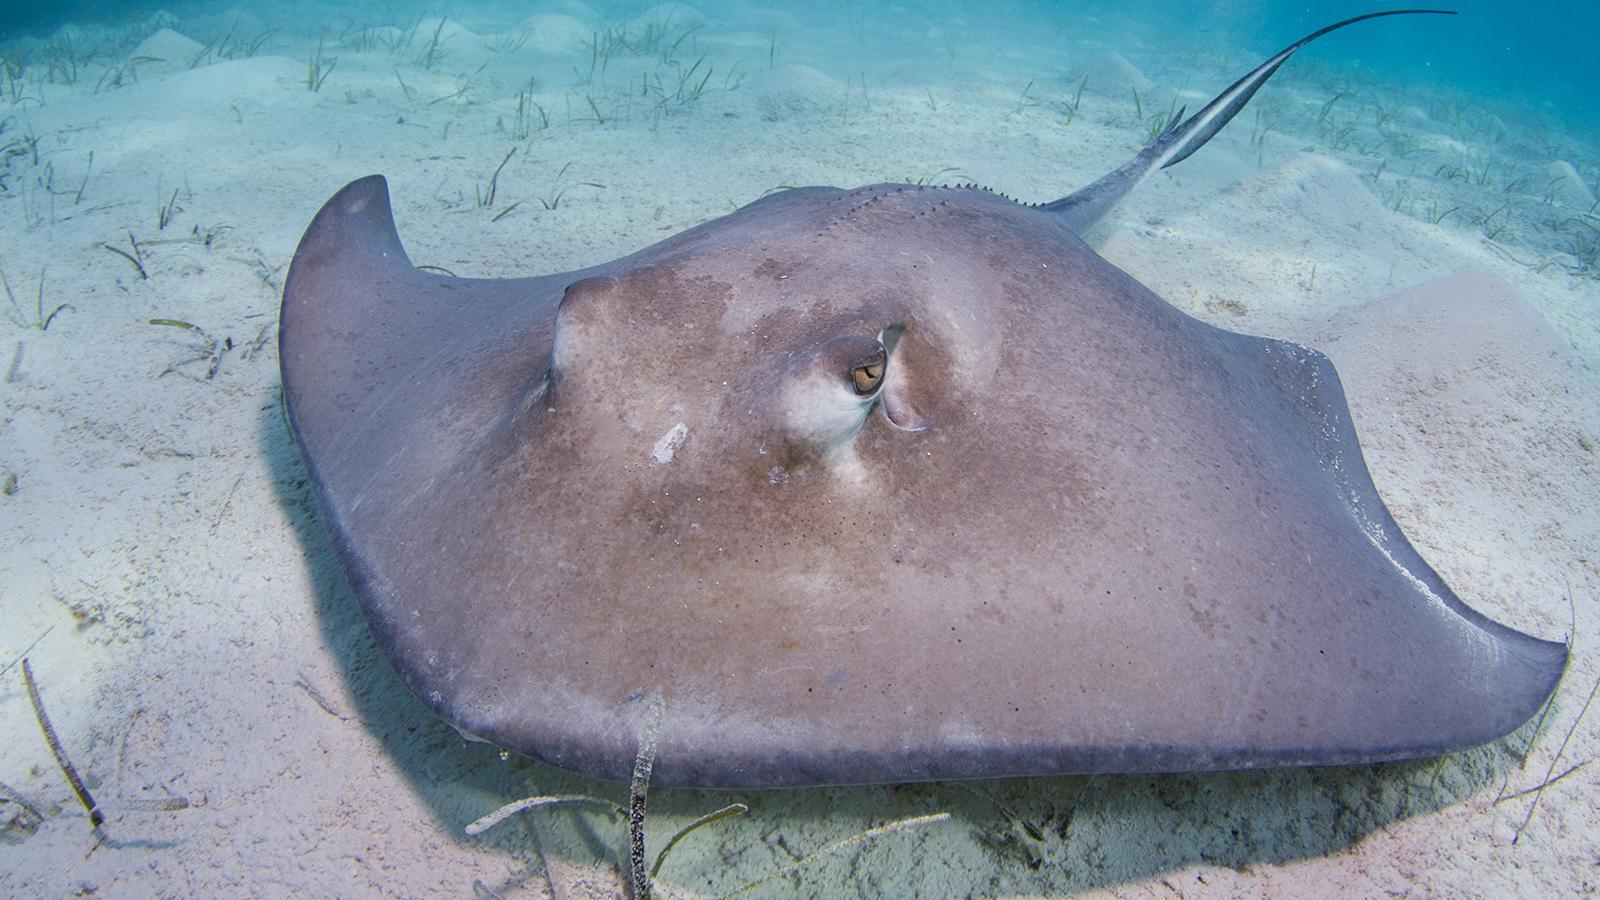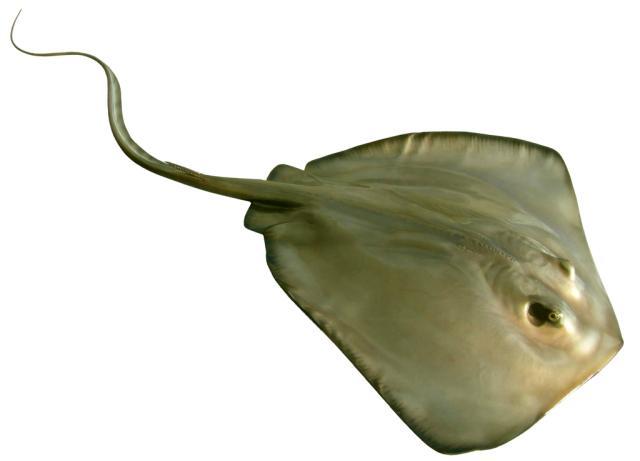The first image is the image on the left, the second image is the image on the right. Evaluate the accuracy of this statement regarding the images: "There is a stingray with its tail going towards a bottom corner.". Is it true? Answer yes or no. No. 